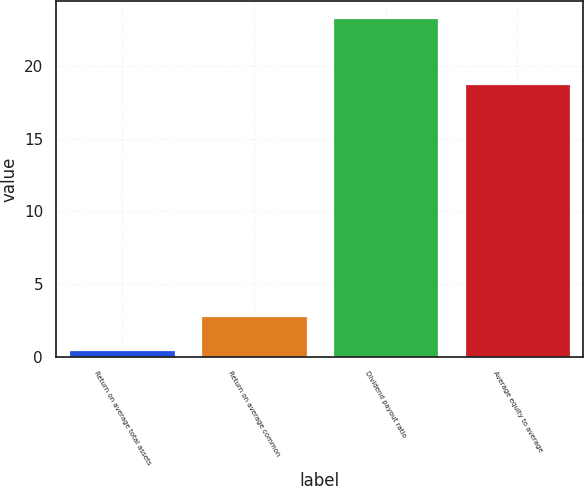Convert chart. <chart><loc_0><loc_0><loc_500><loc_500><bar_chart><fcel>Return on average total assets<fcel>Return on average common<fcel>Dividend payout ratio<fcel>Average equity to average<nl><fcel>0.5<fcel>2.78<fcel>23.31<fcel>18.75<nl></chart> 